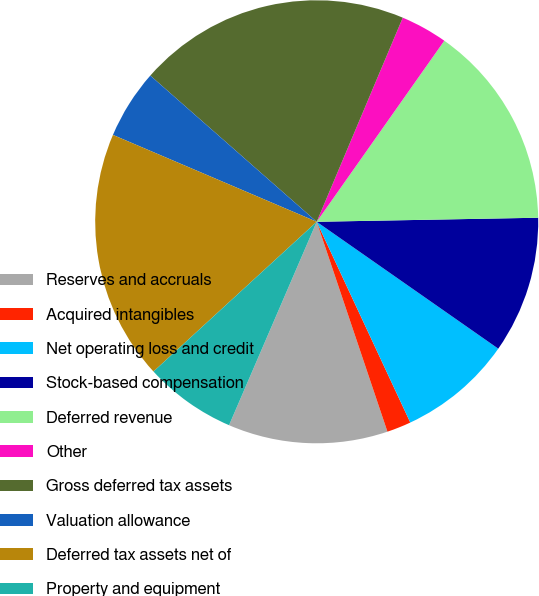Convert chart to OTSL. <chart><loc_0><loc_0><loc_500><loc_500><pie_chart><fcel>Reserves and accruals<fcel>Acquired intangibles<fcel>Net operating loss and credit<fcel>Stock-based compensation<fcel>Deferred revenue<fcel>Other<fcel>Gross deferred tax assets<fcel>Valuation allowance<fcel>Deferred tax assets net of<fcel>Property and equipment<nl><fcel>11.65%<fcel>1.77%<fcel>8.35%<fcel>10.0%<fcel>14.94%<fcel>3.42%<fcel>19.88%<fcel>5.06%<fcel>18.23%<fcel>6.71%<nl></chart> 